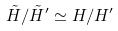<formula> <loc_0><loc_0><loc_500><loc_500>\tilde { H } / \tilde { H } ^ { \prime } \simeq H / H ^ { \prime }</formula> 